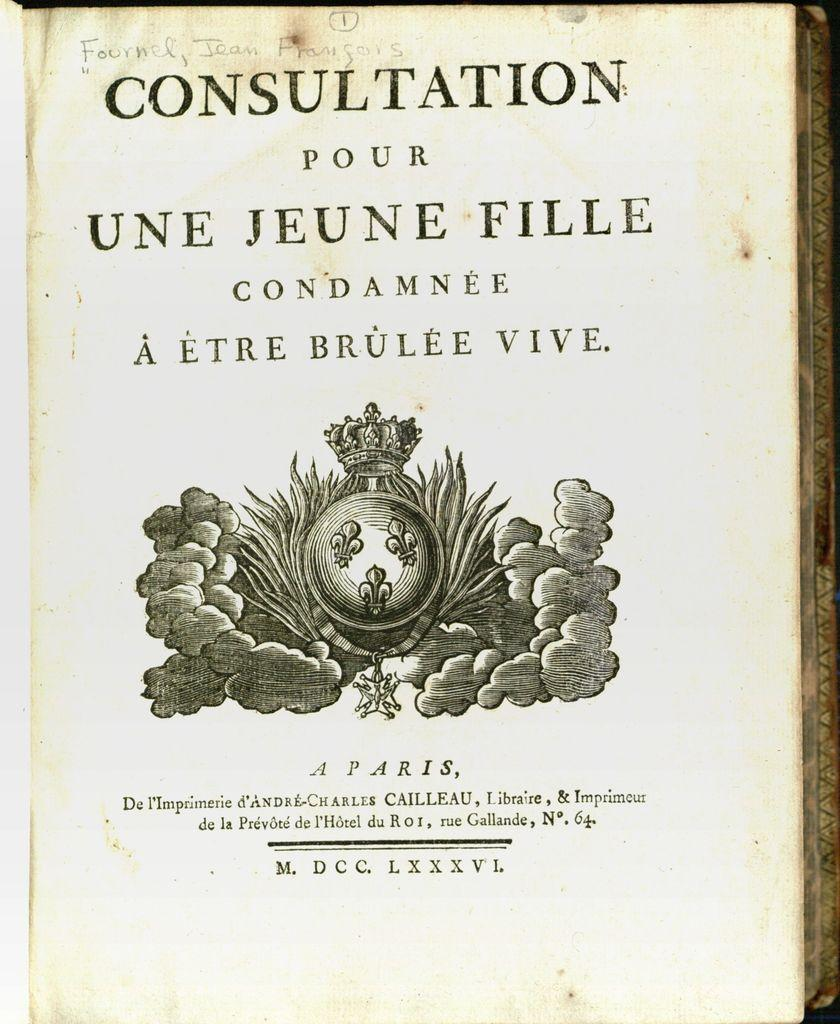<image>
Provide a brief description of the given image. A cover an old looking book with the title CONSULTATION POUR UNE JEUNE FILLE. 